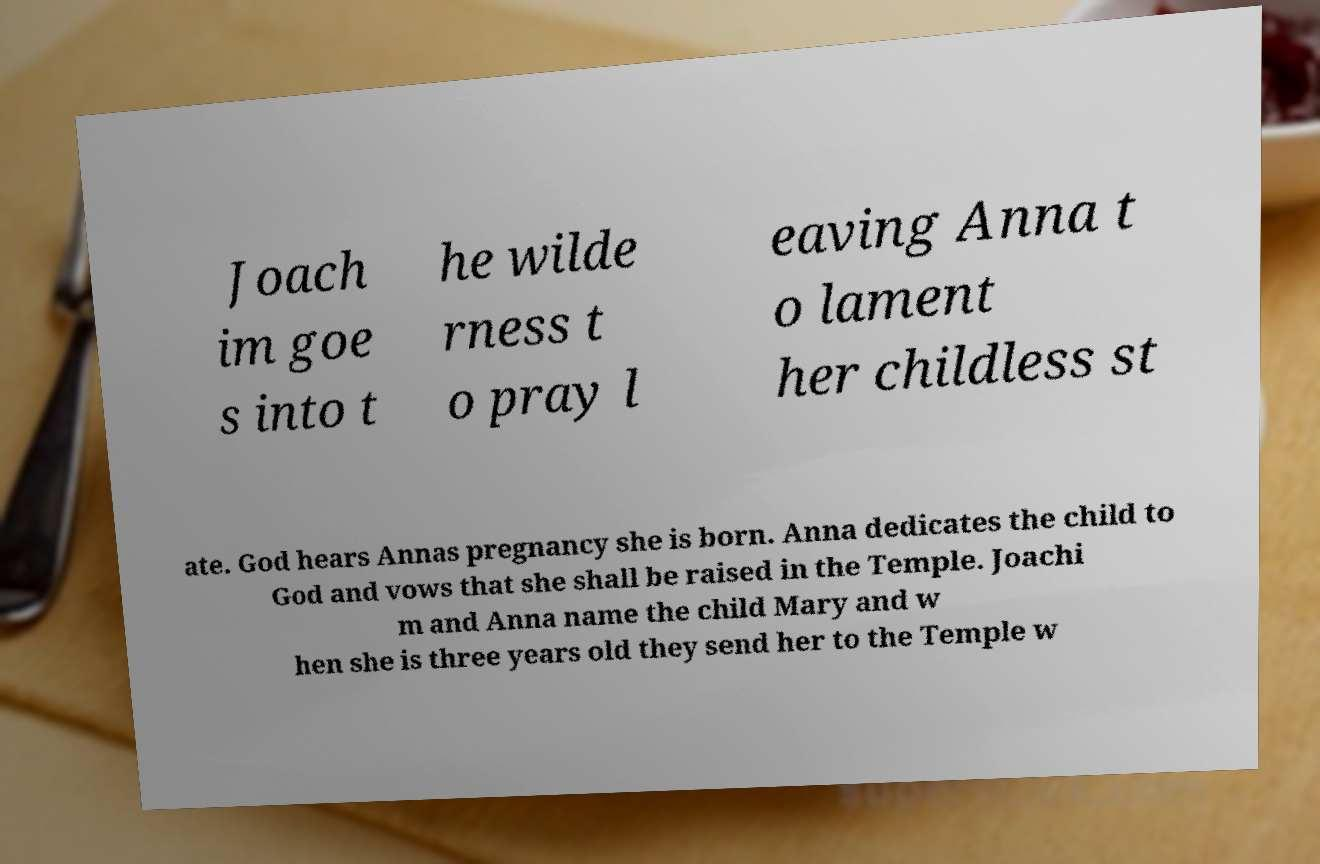Can you accurately transcribe the text from the provided image for me? Joach im goe s into t he wilde rness t o pray l eaving Anna t o lament her childless st ate. God hears Annas pregnancy she is born. Anna dedicates the child to God and vows that she shall be raised in the Temple. Joachi m and Anna name the child Mary and w hen she is three years old they send her to the Temple w 